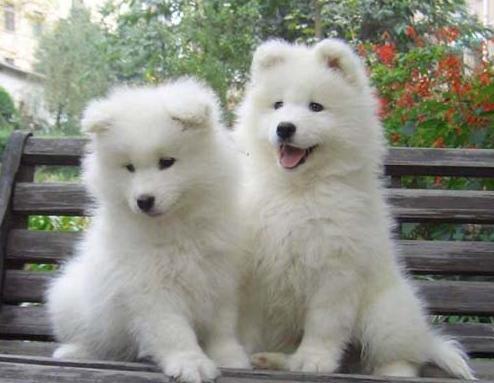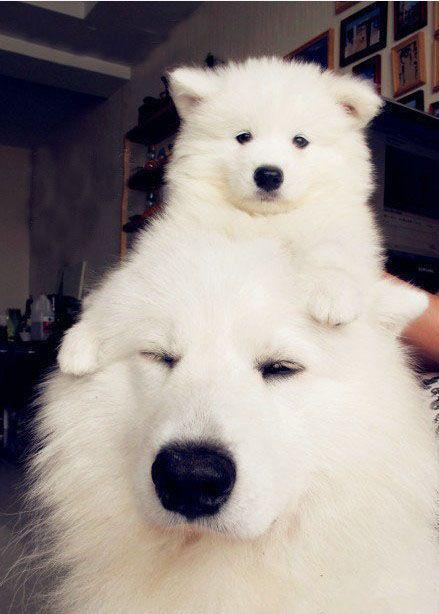The first image is the image on the left, the second image is the image on the right. Examine the images to the left and right. Is the description "There are a total of 5 white dogs." accurate? Answer yes or no. No. 